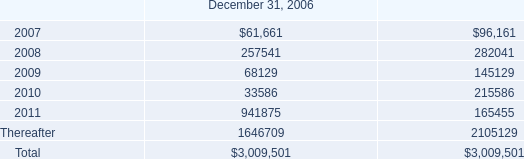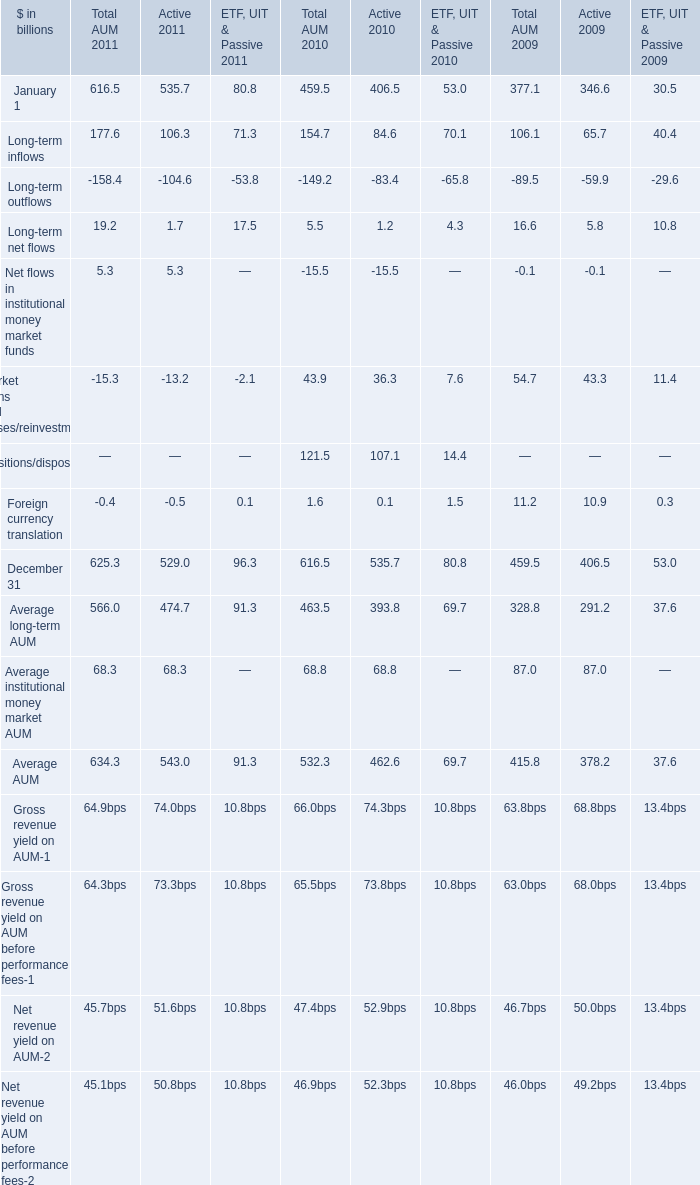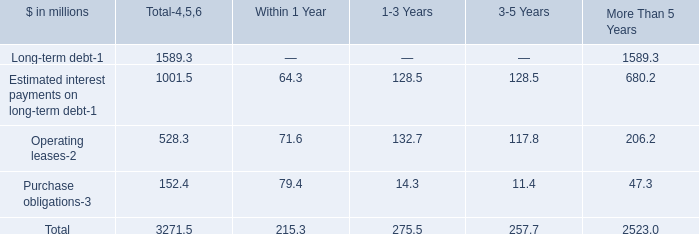What is the sum of the Long-term inflows in the years where Long-term net flows is greater than 6? (in billion) 
Computations: ((177.6 + 154.7) + 106.1)
Answer: 438.4. 